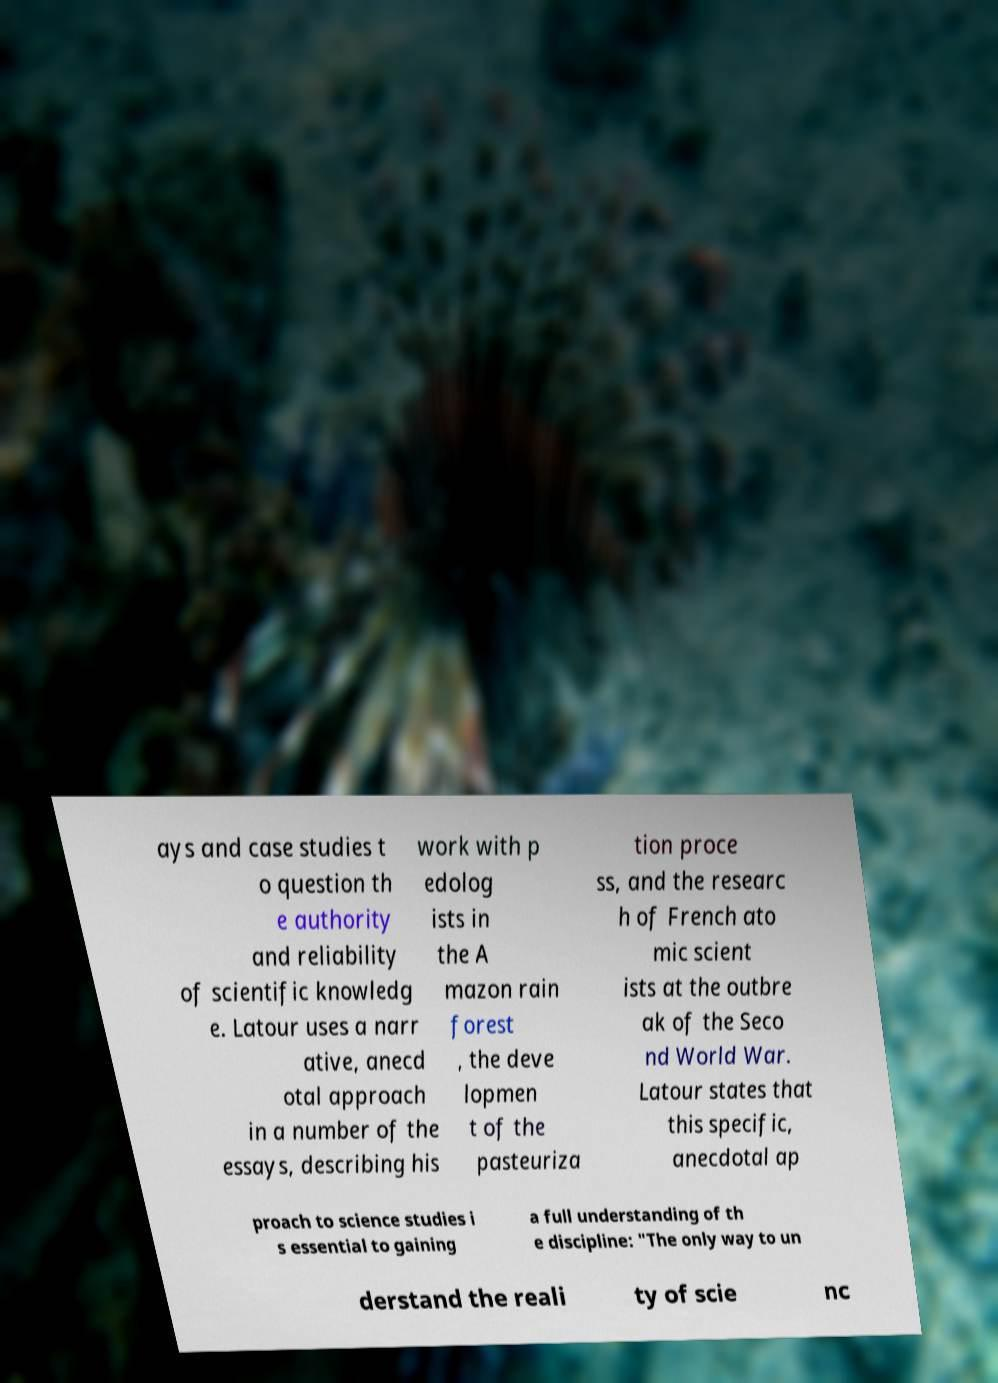There's text embedded in this image that I need extracted. Can you transcribe it verbatim? ays and case studies t o question th e authority and reliability of scientific knowledg e. Latour uses a narr ative, anecd otal approach in a number of the essays, describing his work with p edolog ists in the A mazon rain forest , the deve lopmen t of the pasteuriza tion proce ss, and the researc h of French ato mic scient ists at the outbre ak of the Seco nd World War. Latour states that this specific, anecdotal ap proach to science studies i s essential to gaining a full understanding of th e discipline: "The only way to un derstand the reali ty of scie nc 